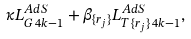<formula> <loc_0><loc_0><loc_500><loc_500>\kappa L _ { G \, 4 k - 1 } ^ { A d S } + \beta _ { \{ r _ { j } \} } L _ { T \, \{ r _ { j } \} \, 4 k - 1 } ^ { A d S } ,</formula> 